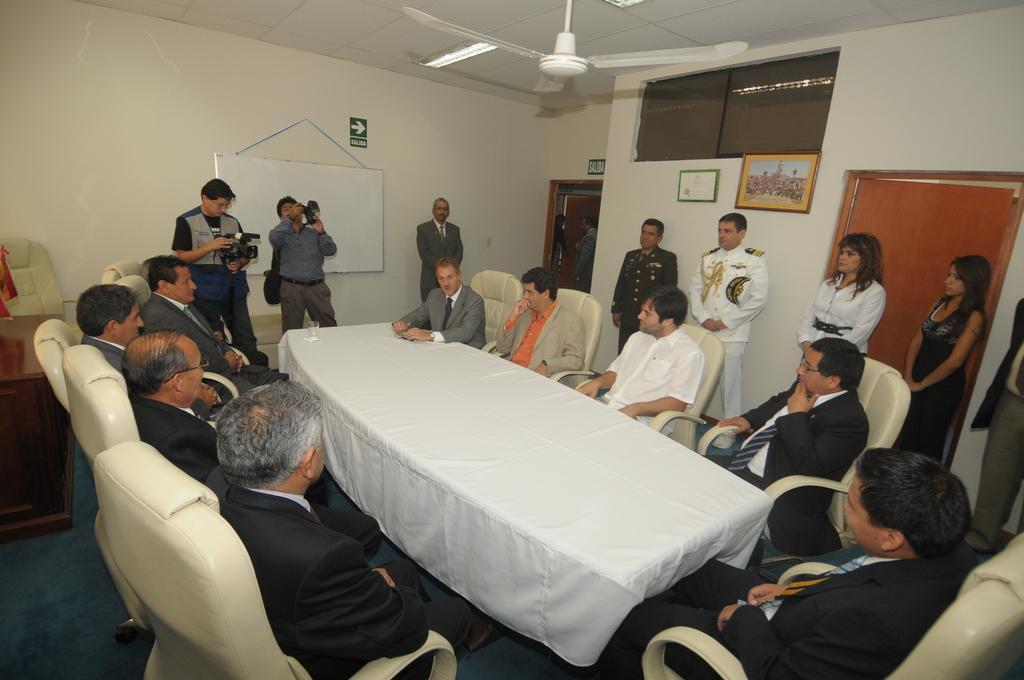Please provide a concise description of this image. A group of people are sitting around the table, many of them wore coats, ties, shirts. On the right side two women are standing, at the top there is a fan in white color. 